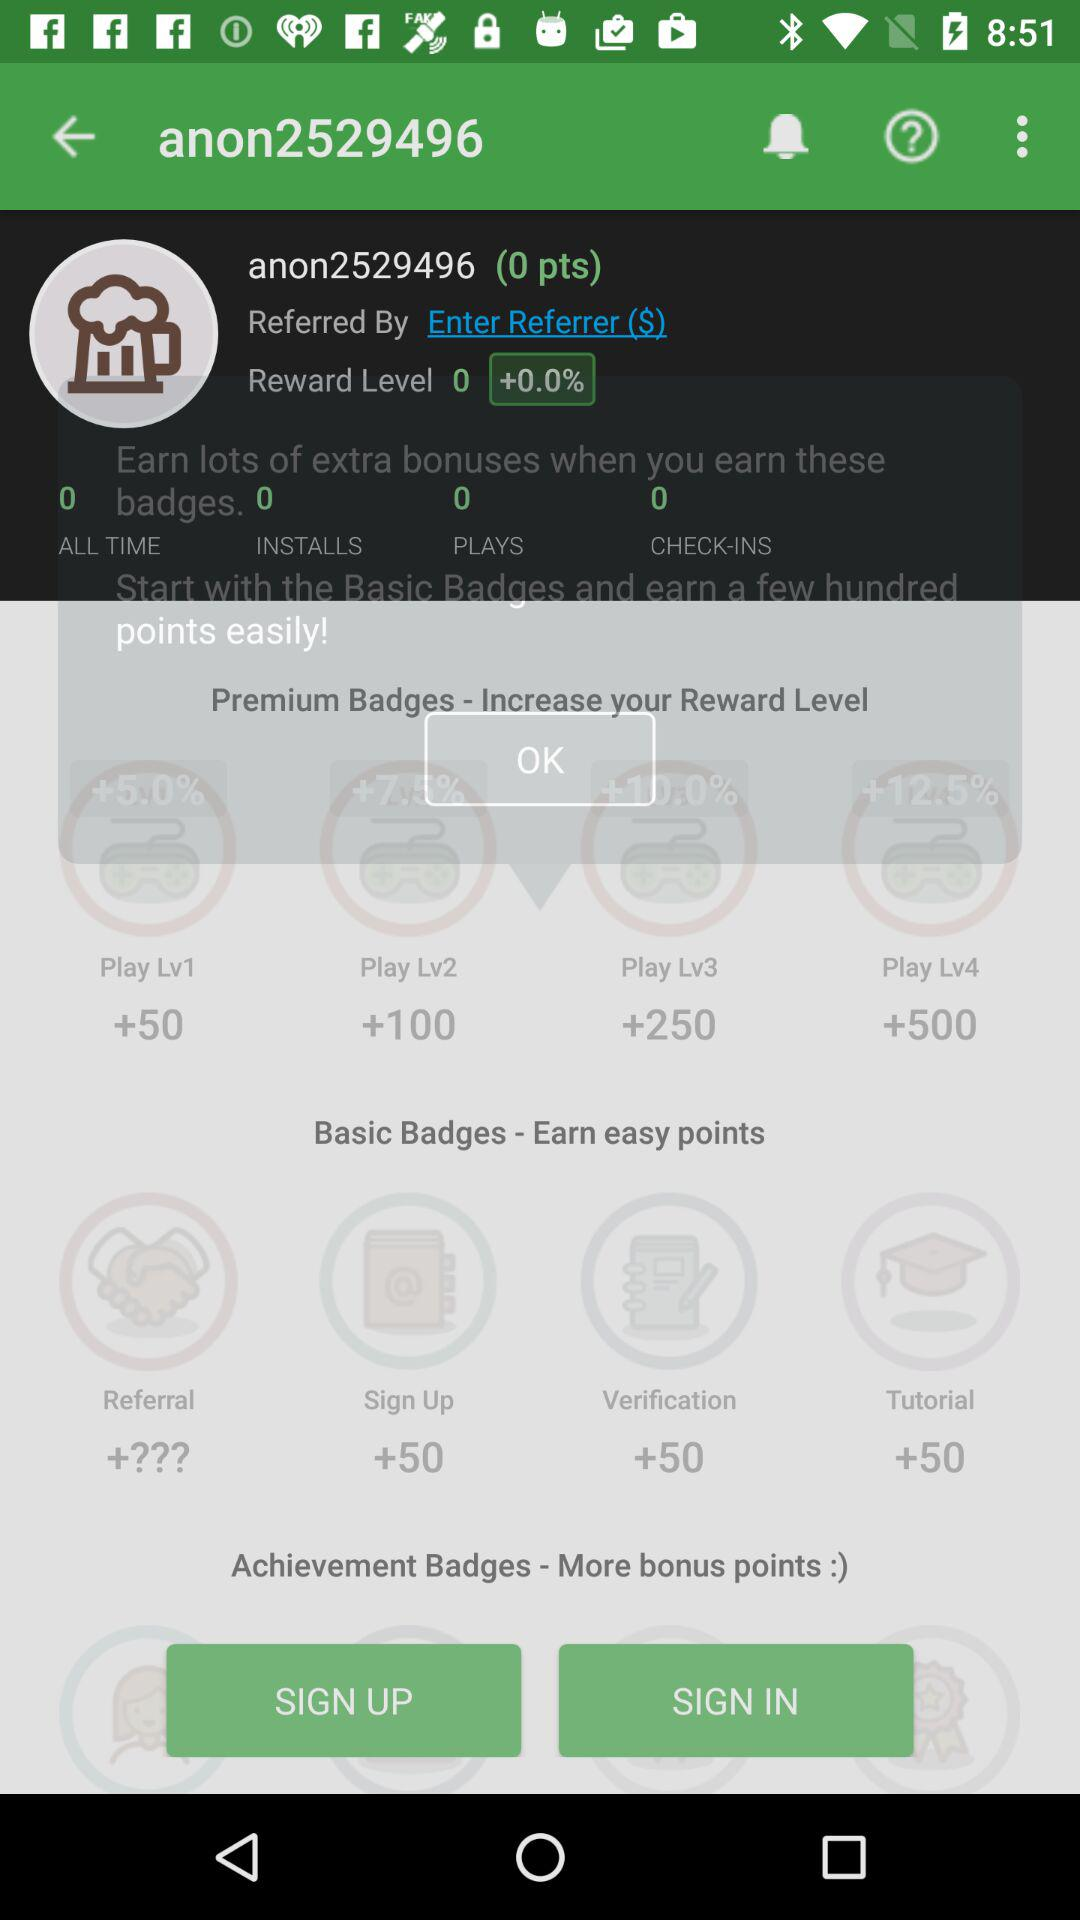How many points are required to reach Level 4?
Answer the question using a single word or phrase. 500 